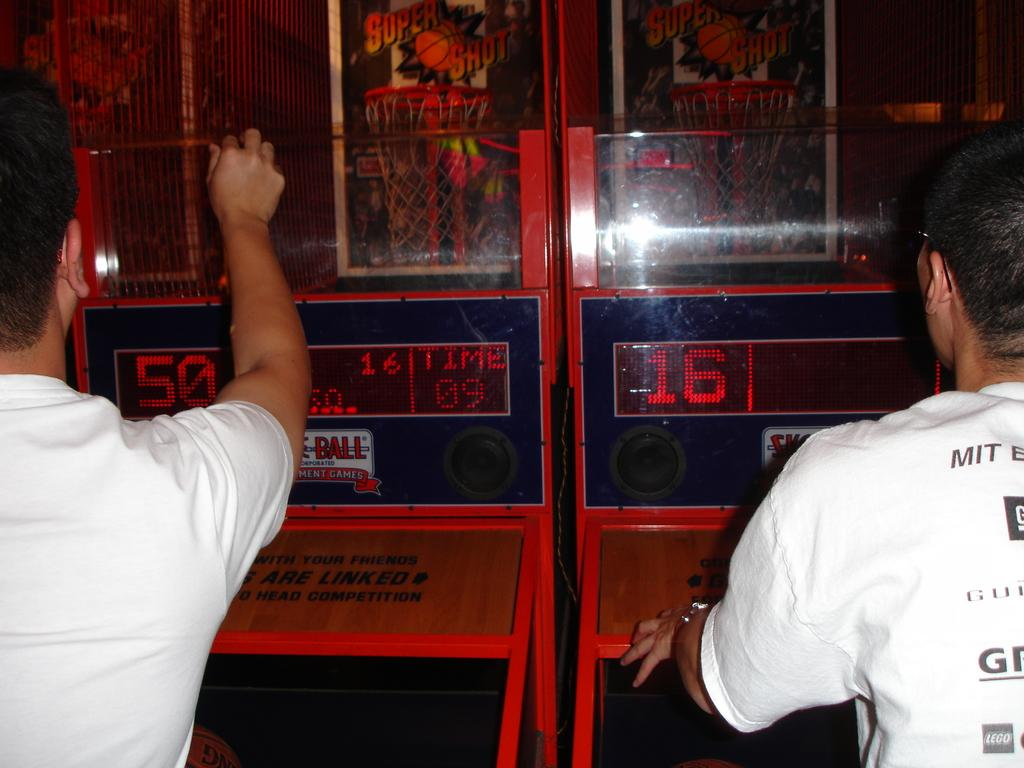How many people are present in the image? There are two people in the image. What else can be seen in the image besides the people? There are machines and posters in the image. Can you describe the unspecified objects in the image? Unfortunately, the provided facts do not specify the nature of the unspecified objects in the image. What is the price of the authority's tongue in the image? There is no mention of a price, authority, or tongue in the image, as these topics are not related to the provided facts. 